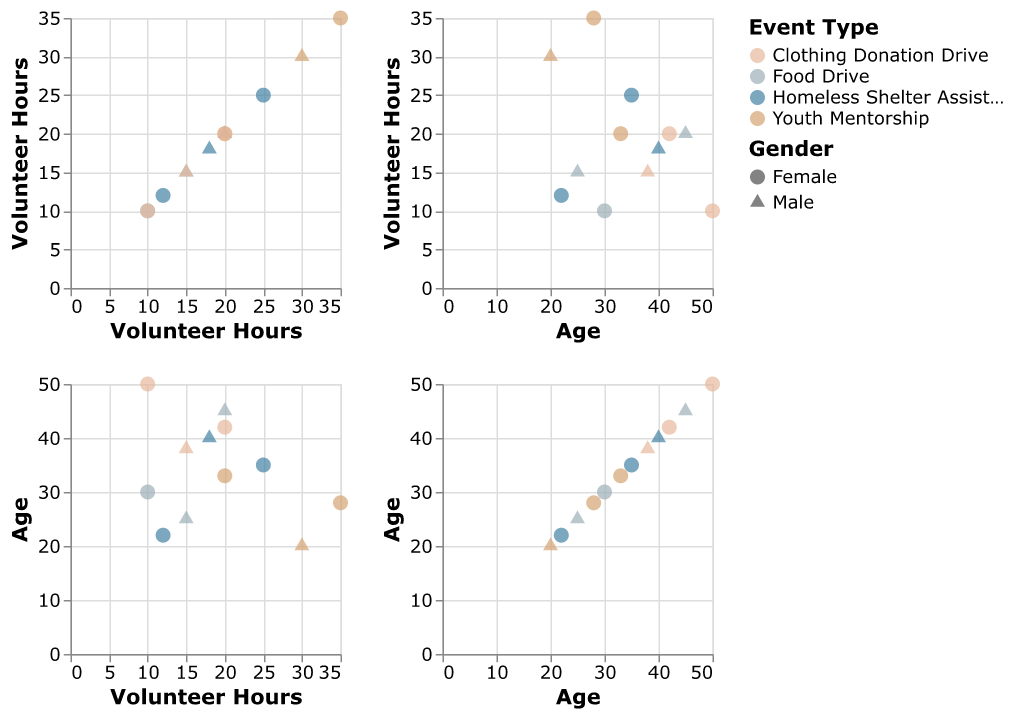What's the general age range of volunteers participating in the Community Outreach Program? To find the general age range, look at the "Age" axis in the scatter plots. The lowest age is 20, and the highest age is 50.
Answer: 20 to 50 How many points represent "Youth Mentorship" events in the scatter plot matrix? Identify the color representing "Youth Mentorship" events, which is a particular color. Count the points of that color in the scatter plot matrix. There are 3 points.
Answer: 3 What is the most common education level among volunteers in "Clothing Donation Drive" events? Use the color for "Clothing Donation Drive" and hover over or identify the points within that event type. There are points for "High School", "Bachelor's", and "Master's". Since there are no repeated education levels, it's equally common for all three.
Answer: "High School", "Bachelor's", "Master's" Which event type has the highest volunteer hours recorded, and how many hours is that? Look for the point with the highest value on the "Volunteer Hours" axis and identify the corresponding event type and the number of hours. The highest volunteer hours are 35, associated with "Youth Mentorship".
Answer: "Youth Mentorship", 35 Which gender tends to volunteer more hours for "Food Drive" events? Identify the shape representative of "Food Drive" and then analyze the points to distinguish between male and female. The male participants volunteered 15 and 20 hours, while female participants volunteered 10 hours.
Answer: Males For volunteers in the age group of 30-40, which event type had the maximum volunteering hours recorded? Locate the points within the age range of 30-40 on the "Age" axis and note their corresponding "Volunteer Hours". Identify which event type these points belong to and find the maximum hours. "Homeless Shelter Assistance" had the maximum hours recorded at 25.
Answer: Homeless Shelter Assistance Which combination of "Education Level" and "Gender" shows more participation in "Homeless Shelter Assistance" events? Look at points specific to "Homeless Shelter Assistance" and note the "Education Level" and "Gender" combinations. Compare and identify the most frequent combination. Both "Bachelor's, Female" and "High School, Male" combinations exist, but there is no dominance as they are equally present.
Answer: Equal between "Bachelor's, Female" and "High School, Male" Between "Food Drive" and "Clothing Donation Drive", which event type shows a higher average age of volunteers? Calculate the average age for each event type by adding the ages and dividing by the number of points. For "Food Drive", the average is (25+30+45)/3 = 33.33. For "Clothing Donation Drive", the average is (50+38+42)/3 = 43.33. Therefore, "Clothing Donation Drive" has a higher average age.
Answer: Clothing Donation Drive Considering volunteers with a Master's degree, which event type records the highest number of volunteer hours? Filter out points where "Education Level" is "Master's" and compare their "Volunteer Hours". "Food Drive" has 20 hours, "Homeless Shelter Assistance" has 12 hours, "Youth Mentorship" has 20 hours, and "Clothing Donation Drive" has 20 hours. Thus, multiple event types (Food Drive, Youth Mentorship, Clothing Donation Drive) are tied for the highest hours recorded by Master's degree holders.
Answer: Food Drive, Youth Mentorship, Clothing Donation Drive 